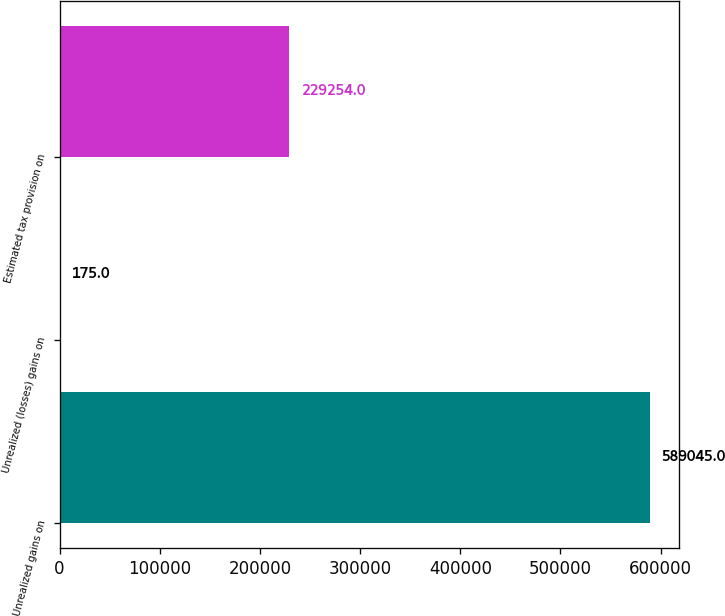Convert chart. <chart><loc_0><loc_0><loc_500><loc_500><bar_chart><fcel>Unrealized gains on<fcel>Unrealized (losses) gains on<fcel>Estimated tax provision on<nl><fcel>589045<fcel>175<fcel>229254<nl></chart> 